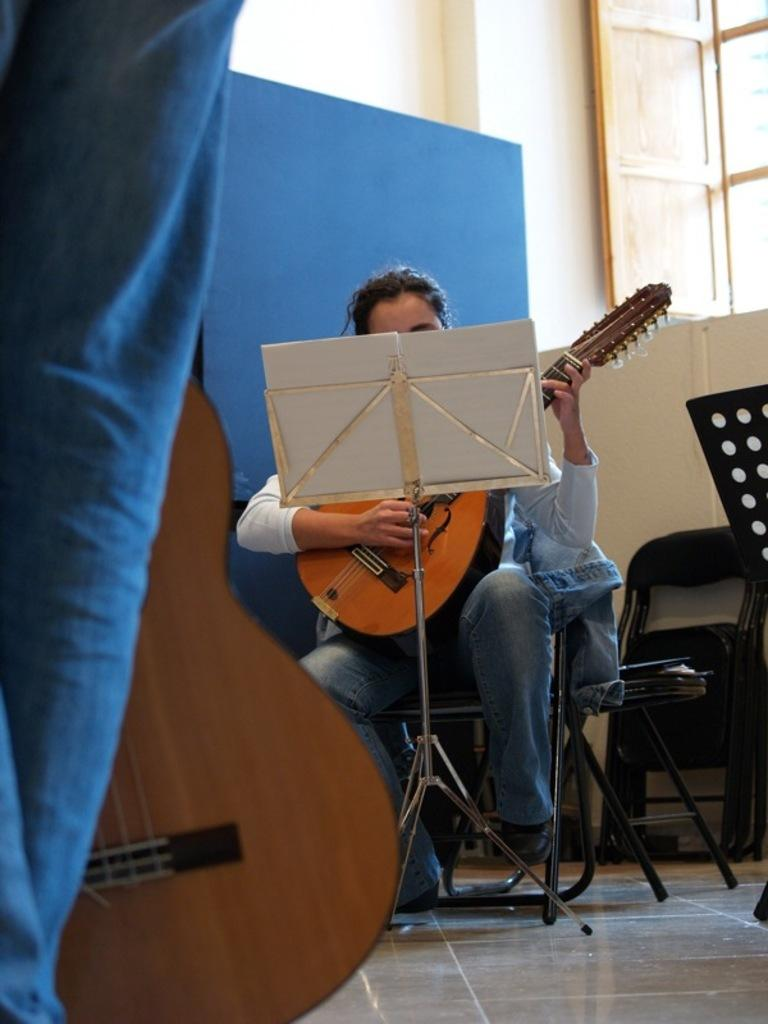What is the person sitting on a chair doing in the image? The person sitting on a chair is playing a guitar. What object is in front of the person playing the guitar? There is a book stand in front of the person. What is the man standing and holding a guitar doing? The man standing and holding a guitar is likely preparing to play or has just finished playing. Can you describe the window in the image? There is a window with doors in the image. How many boys are on the team in the image? There is no team or boys present in the image. What type of tank can be seen in the image? There is no tank present in the image. 